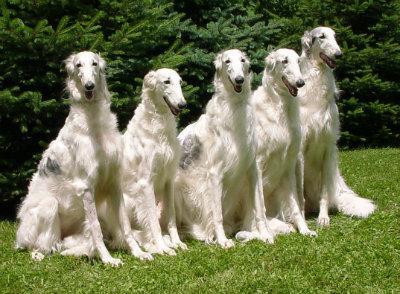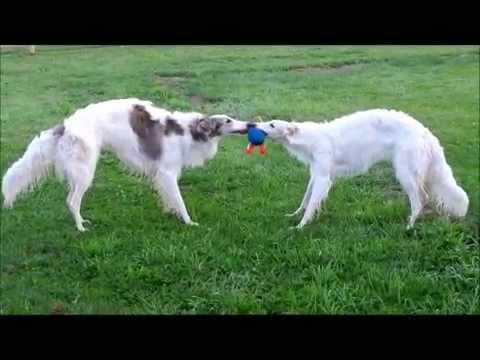The first image is the image on the left, the second image is the image on the right. For the images displayed, is the sentence "There are two dogs" factually correct? Answer yes or no. No. 